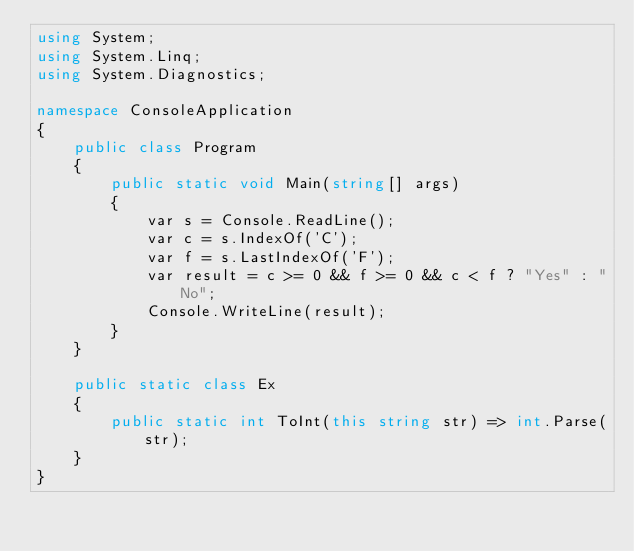Convert code to text. <code><loc_0><loc_0><loc_500><loc_500><_C#_>using System;
using System.Linq;
using System.Diagnostics;

namespace ConsoleApplication
{
    public class Program
    {
        public static void Main(string[] args)
        {
            var s = Console.ReadLine();
            var c = s.IndexOf('C');
            var f = s.LastIndexOf('F');
            var result = c >= 0 && f >= 0 && c < f ? "Yes" : "No";
            Console.WriteLine(result);
        }
    }

    public static class Ex
    {
        public static int ToInt(this string str) => int.Parse(str);
    }
}
</code> 